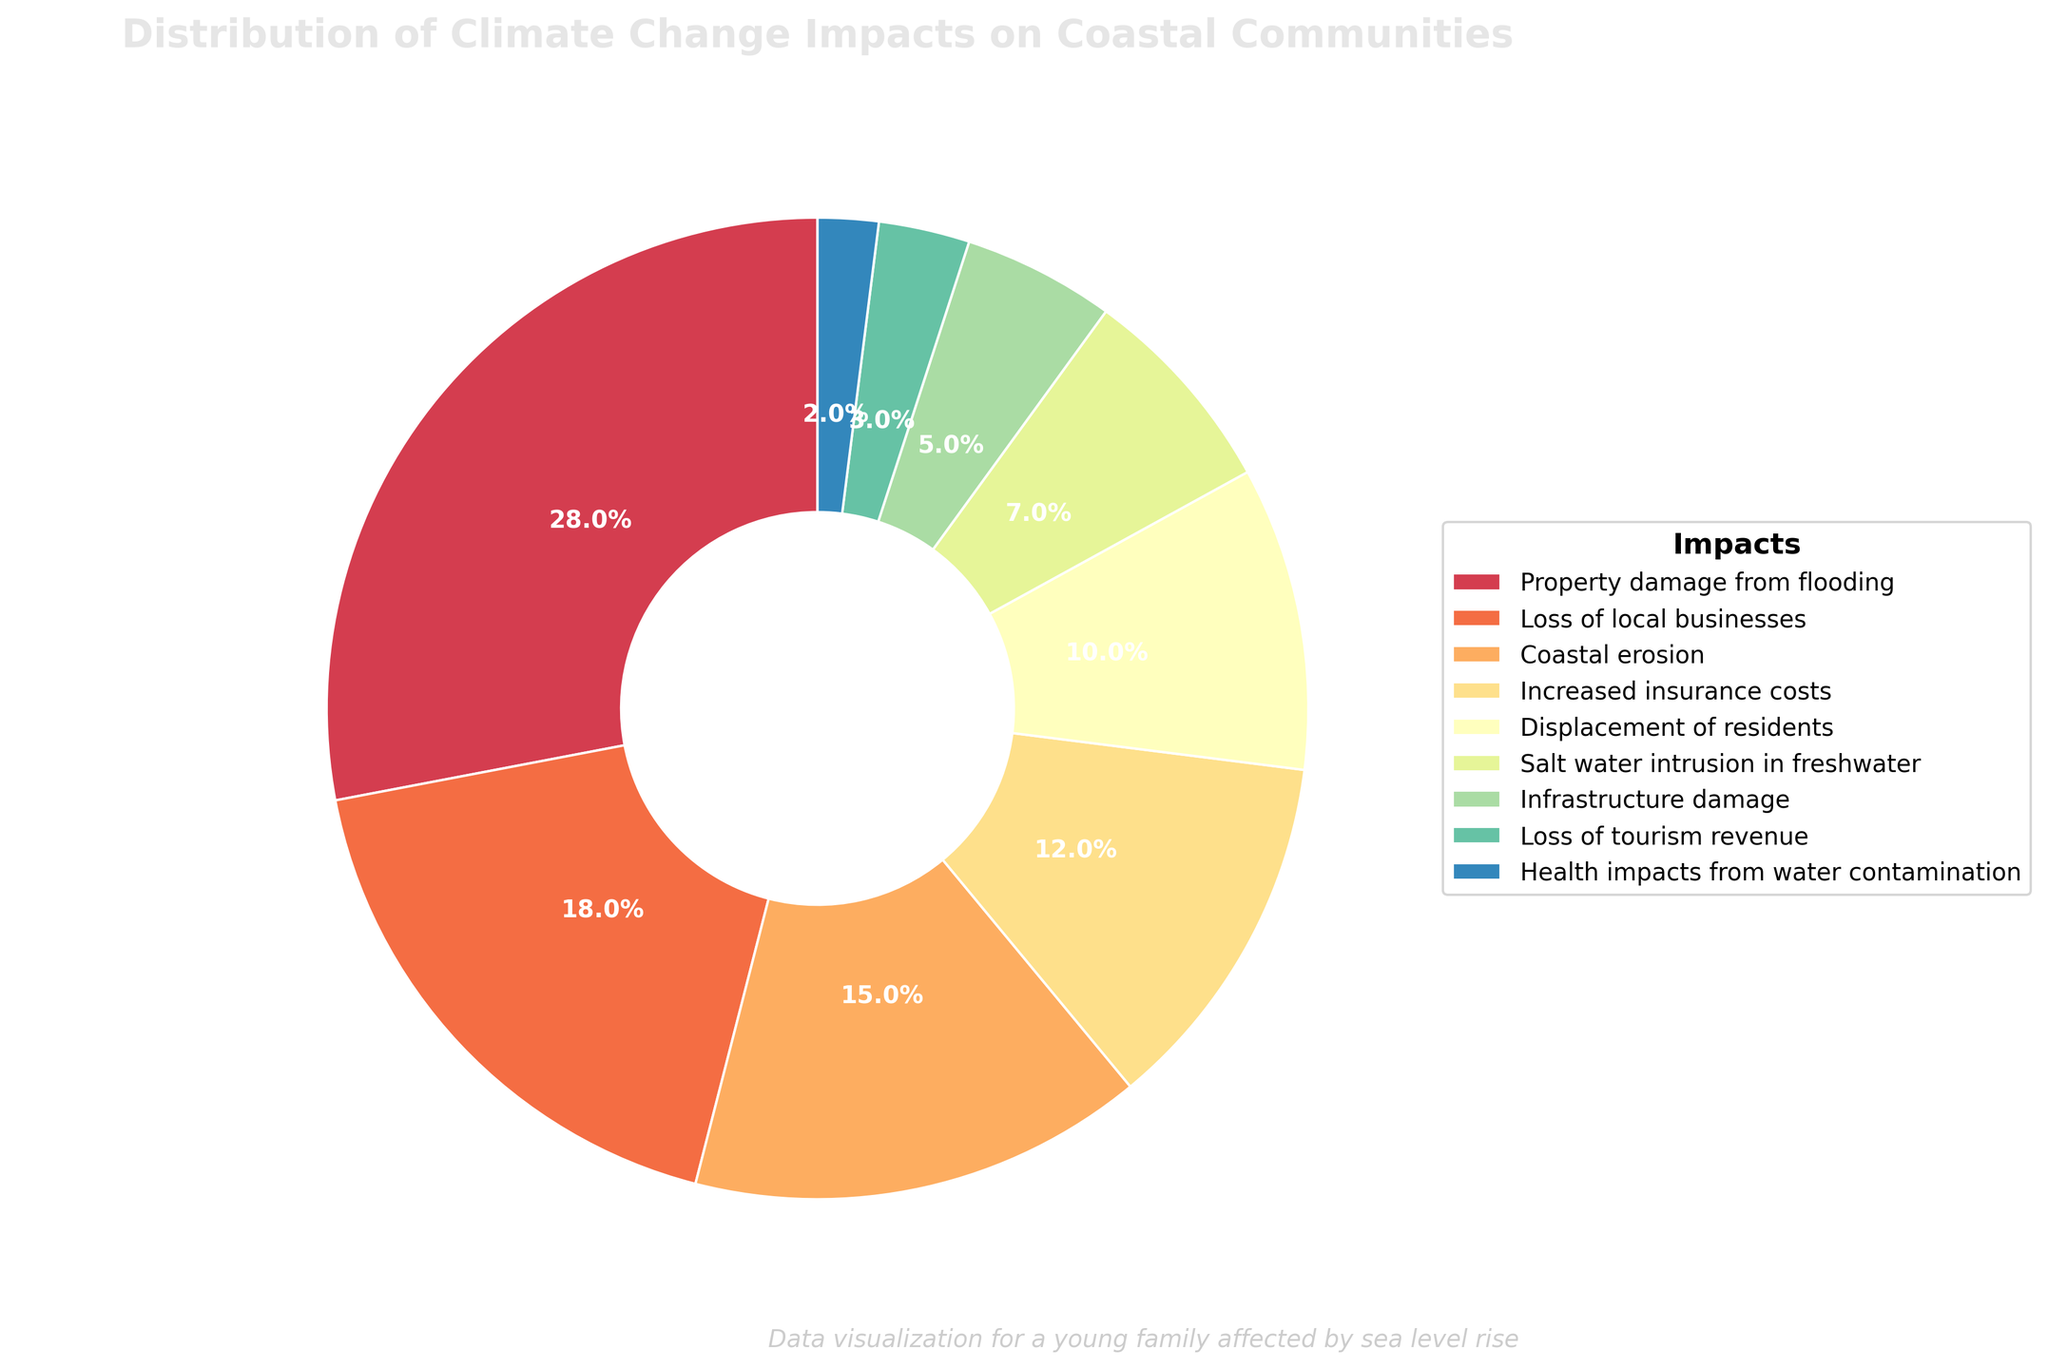What's the largest impact of climate change on coastal communities? The figure shows that "Property damage from flooding" occupies the largest portion of the pie chart at 28%, making it the largest impact.
Answer: Property damage from flooding Which two impacts have the smallest percentages? By looking at the pie chart, the two smallest segments are "Health impacts from water contamination" at 2% and "Loss of tourism revenue" at 3%.
Answer: Health impacts from water contamination and Loss of tourism revenue How much more significant is "Property damage from flooding" compared to "Displacement of residents"? "Property damage from flooding" is 28%, while "Displacement of residents" is 10%. The difference is 28% - 10% = 18%. Therefore, "Property damage from flooding" is 18% more significant.
Answer: 18% What percentage of the impacts is due to economic factors (property damage, increased insurance costs, and loss of tourism revenue)? Sum "Property damage from flooding" (28%), "Increased insurance costs" (12%), and "Loss of tourism revenue" (3%). So, 28% + 12% + 3% = 43%.
Answer: 43% Are there more impacts related to physical infrastructure than to commercial aspects? Physical infrastructure-related impacts are "Property damage from flooding" (28%), "Coastal erosion" (15%), "Infrastructure damage" (5%) totaling 48%. Commercial aspects are "Loss of local businesses" (18%), "Increased insurance costs" (12%), and "Loss of tourism revenue" (3%) totaling 33%. Thus, 48% is greater than 33%.
Answer: Yes Which impact has a percentage closest to the average of all impacts? First, sum all percentages: 28 + 18 + 15 + 12 + 10 + 7 + 5 + 3 + 2 = 100%. With 9 impacts, the average is 100/9 ≈ 11.11%. "Increased insurance costs" at 12% is closest to this average.
Answer: Increased insurance costs What is the combined percentage of "Infrastructure damage" and "Salt water intrusion in freshwater"? Sum "Infrastructure damage" (5%) and "Salt water intrusion in freshwater" (7%) to get 5% + 7% = 12%.
Answer: 12% Which two impacts combined have a larger percentage than "Coastal erosion"? "Loss of local businesses" (18%) combined with "Health impacts from water contamination" (2%) totals 18% + 2% = 20%, which is larger than "Coastal erosion" at 15%.
Answer: Loss of local businesses and Health impacts from water contamination If "Property damage from flooding" were to increase by 4%, how would its new percentage compare to the combined percentage of "Coastal erosion" and "Displacement of residents"? New percentage for "Property damage from flooding" would be 28% + 4% = 32%. "Coastal erosion" (15%) and "Displacement of residents" (10%) combined is 15% + 10% = 25%. 32% is greater than 25%.
Answer: Greater What is the difference in percentage between "Loss of local businesses" and "Infrastructure damage"? "Loss of local businesses" is 18% and "Infrastructure damage" is 5%. The difference is 18% - 5% = 13%.
Answer: 13% 